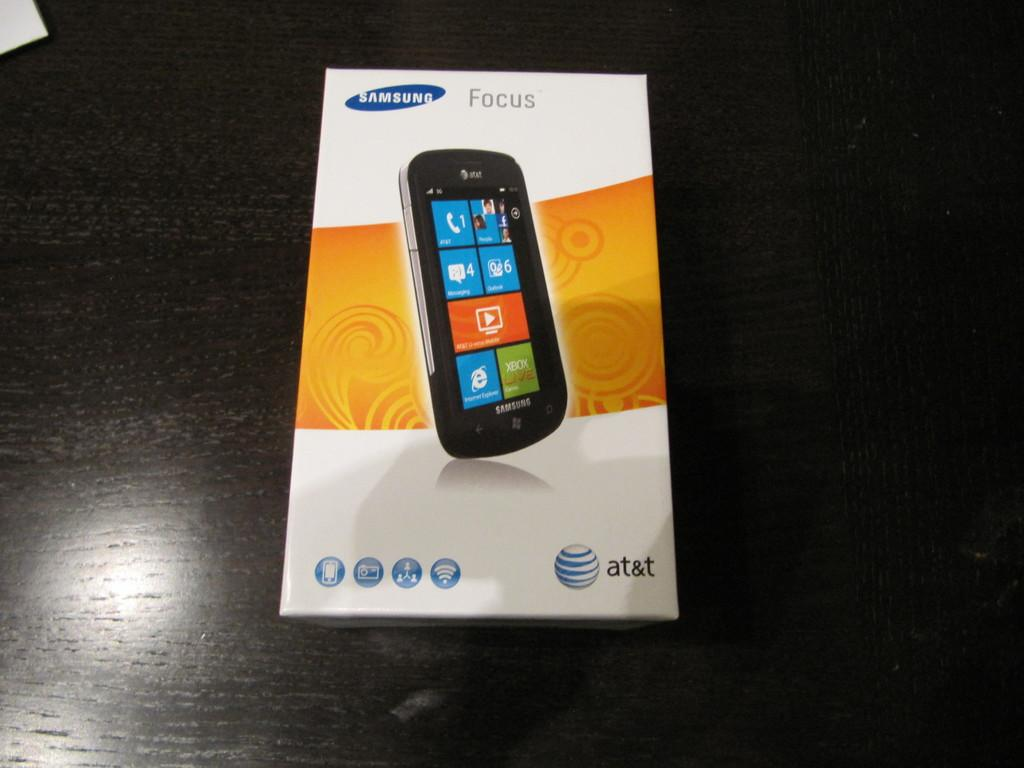What is the main object in the image? There is a box in the image. What is the box placed on? The box is on a wooden object. What brand or company is associated with the box? The word "Samsung" is written on the box. What type of wilderness is visible in the background of the image? There is no wilderness visible in the image; it only shows a box on a wooden object with the word "Samsung" written on it. 